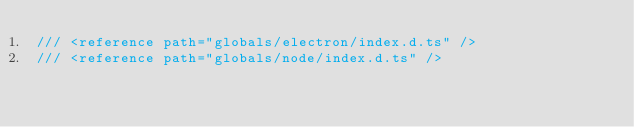<code> <loc_0><loc_0><loc_500><loc_500><_TypeScript_>/// <reference path="globals/electron/index.d.ts" />
/// <reference path="globals/node/index.d.ts" />
</code> 